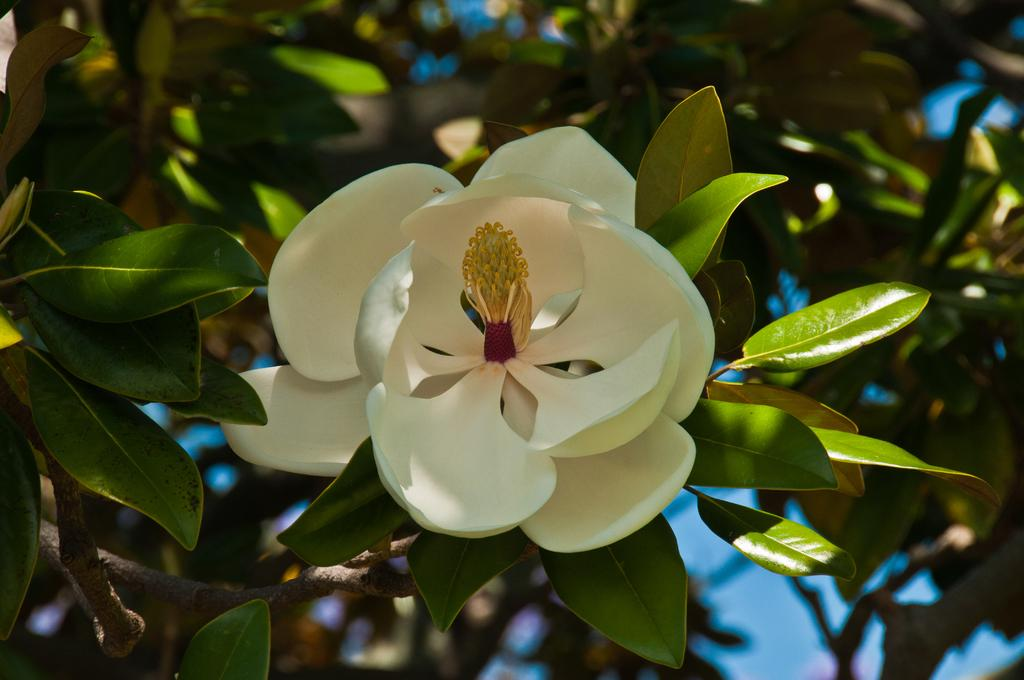What type of plant can be seen in the image? There is a flower and many leaves on a plant in the image. Can you describe the flower in the image? Unfortunately, the facts provided do not give enough detail to describe the flower. How many leaves are visible on the plant in the image? The facts provided do not specify the number of leaves on the plant. What word is being cast by the light in the image? There is no mention of light or casting in the image, so it is not possible to answer that question. 